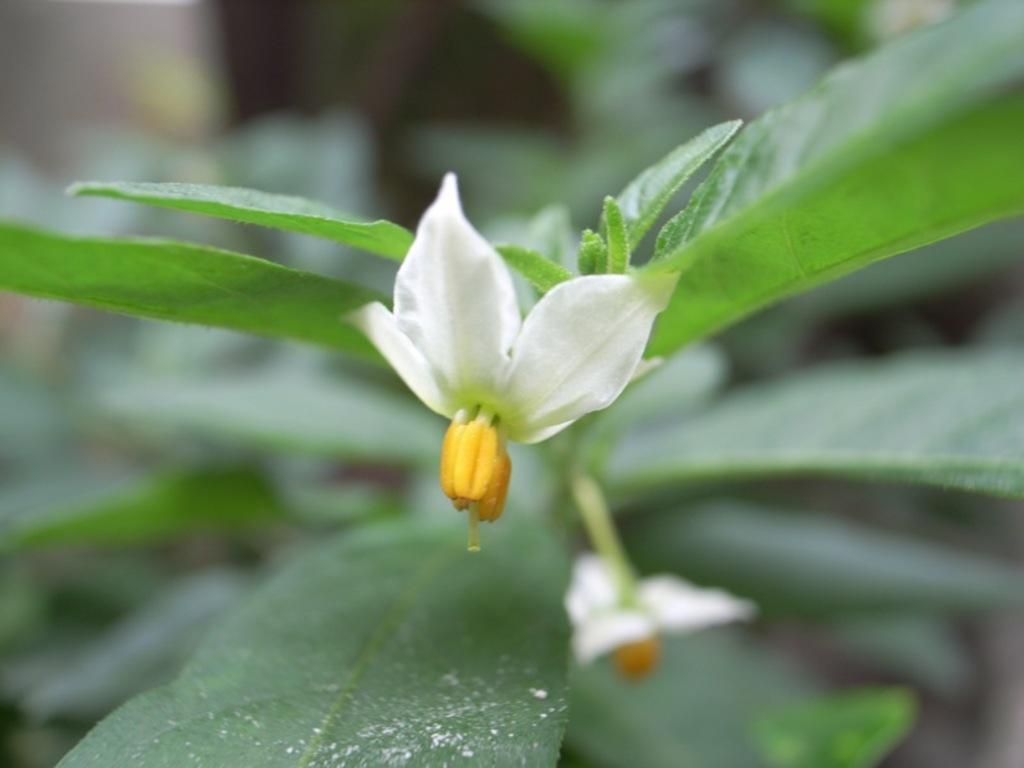What is the main subject of the image? There is a flower in the image. What else can be seen around the flower? There are leaves surrounding the flower in the image. Can you see a sheet covering the flower in the image? No, there is no sheet covering the flower in the image. Is there a lake visible in the background of the image? No, there is no lake visible in the image; it only features a flower and leaves. 